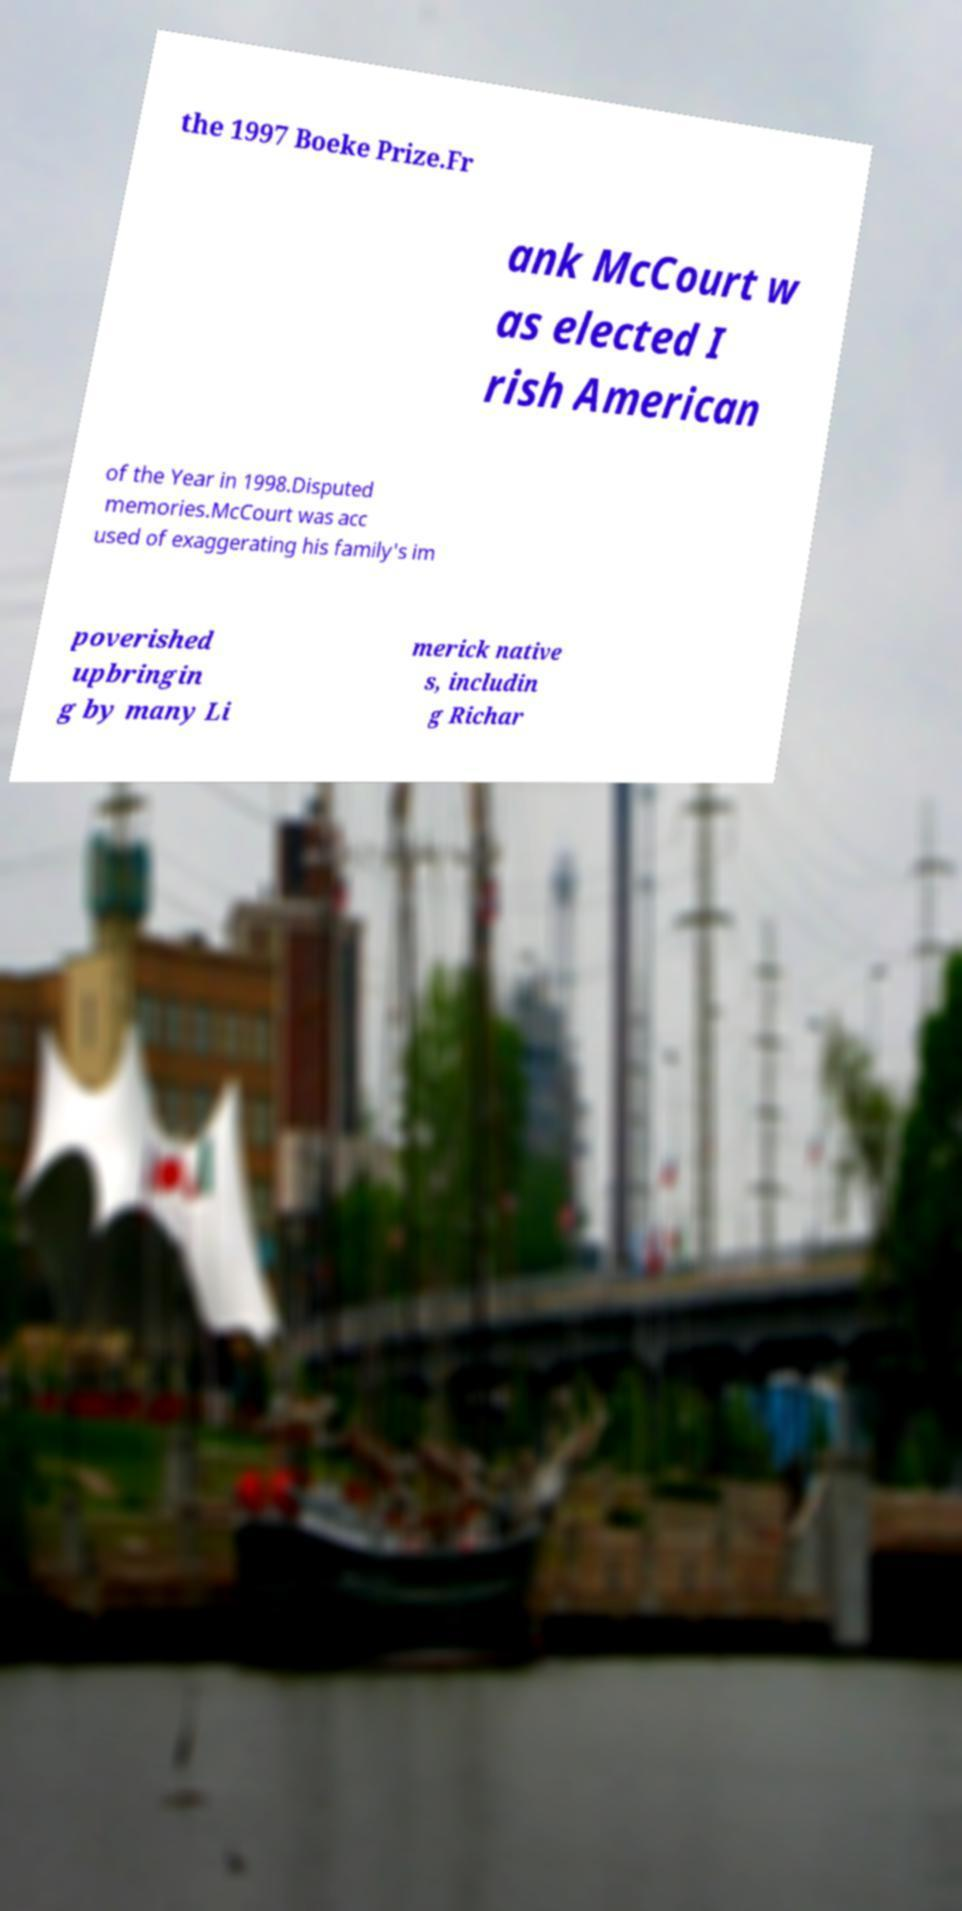I need the written content from this picture converted into text. Can you do that? the 1997 Boeke Prize.Fr ank McCourt w as elected I rish American of the Year in 1998.Disputed memories.McCourt was acc used of exaggerating his family's im poverished upbringin g by many Li merick native s, includin g Richar 